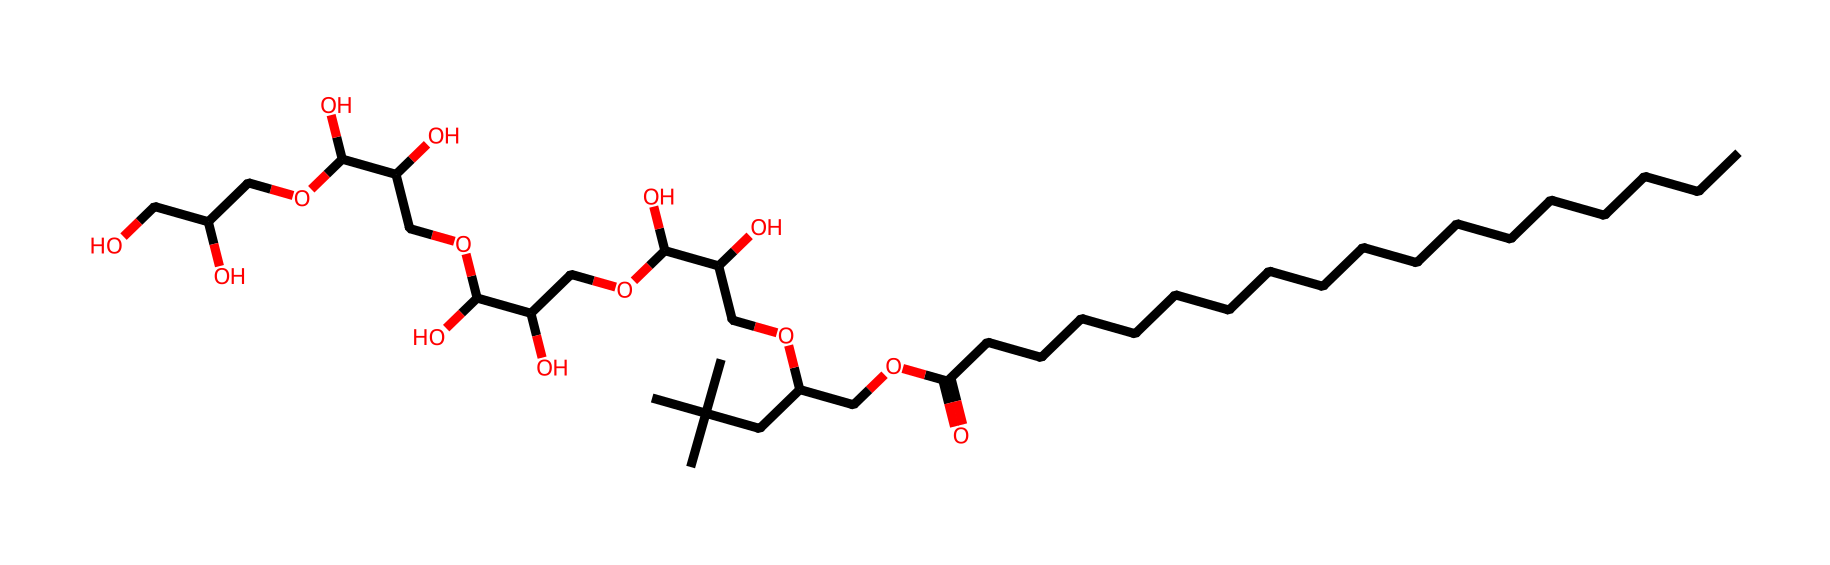What is the total number of carbon atoms in polysorbate 80? By analyzing the provided SMILES representation, we can count the number of carbon (C) atoms. The string indicates a long carbon chain followed by several branching groups, and by systematic tallying, we find a total of 20 carbon atoms.
Answer: 20 How many oxygen atoms are present in polysorbate 80? In the SMILES structure, we notice the presence of oxygen (O) atoms appearing multiple times. Counting these occurrences throughout the structure gives us a total of 16 oxygen atoms.
Answer: 16 Which functional groups are indicated in the chemical structure of polysorbate 80? Reviewing the SMILES, we observe several functional groups: there are carboxyl groups (-COOH), hydroxyl groups (-OH), and ether links (-O-). These groups can be identified by their characteristic placements in the structure.
Answer: carboxyl, hydroxyl, ether What is the primary use of polysorbate 80 in manufacturing? Polysorbate 80 is primarily used as an emulsifier in food and pharmaceutical manufacturing. This is indicated by its properties linked to surfactancy that allow it to stabilize mixtures of oil and water.
Answer: emulsifier How does the presence of hydroxyl groups affect the properties of polysorbate 80? The hydroxyl groups (-OH) enhance the hydrophilicity of polysorbate 80, promoting strong interactions with water and improving its ability to dissolve in aqueous environments, which is critical for its function as an emulsifier.
Answer: increases hydrophilicity Which part of the polysorbate structure contributes to its surfactant properties? The long hydrophobic carbon chain contributes to the surfactant properties of polysorbate 80, providing a nonpolar tail that interacts with oil, while the hydrophilic head (containing several hydroxyl and ether groups) interacts with water, enabling emulsification.
Answer: hydrophobic carbon chain 